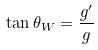Convert formula to latex. <formula><loc_0><loc_0><loc_500><loc_500>\tan \theta _ { W } = \frac { g ^ { \prime } } { g }</formula> 